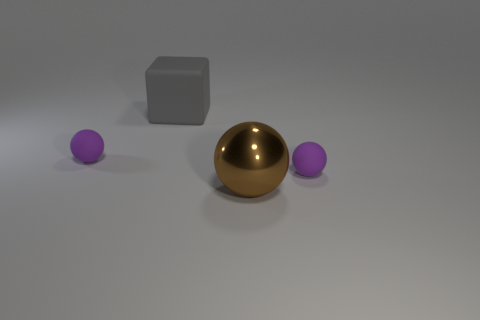Are there any brown balls that have the same size as the gray block? Indeed, there is a brown ball that appears to match the size of the grey block quite closely. It is positioned between two smaller purple balls, creating a striking contrast in both color and proportions. 